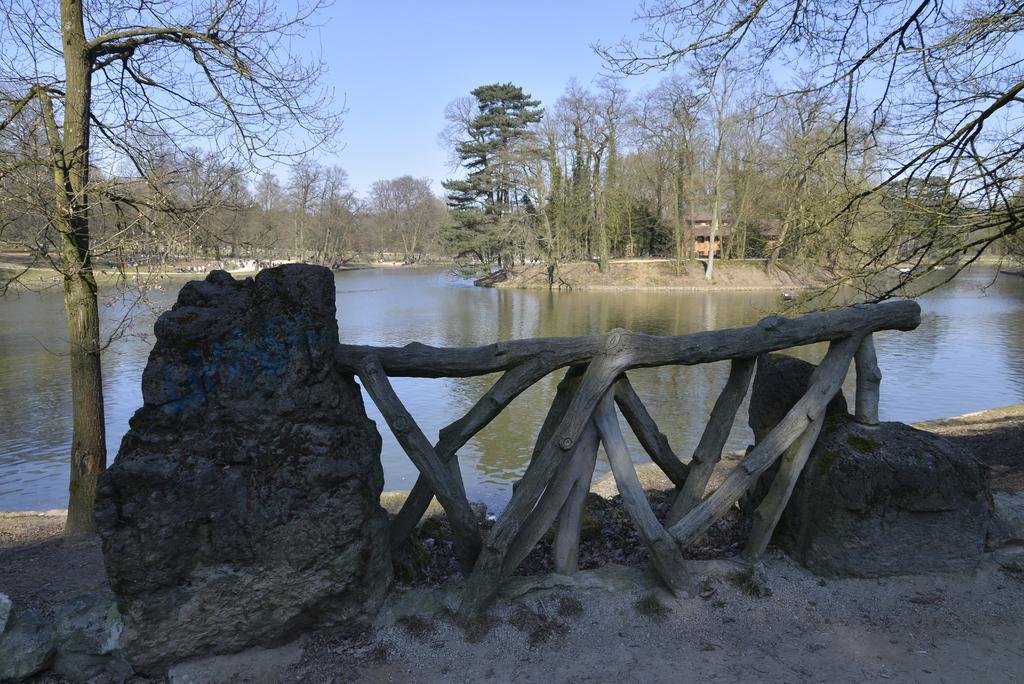Can you describe this image briefly? In the picture I can see stones, wooden logs, in the background of the picture there is water, there are some trees and clear sky. 